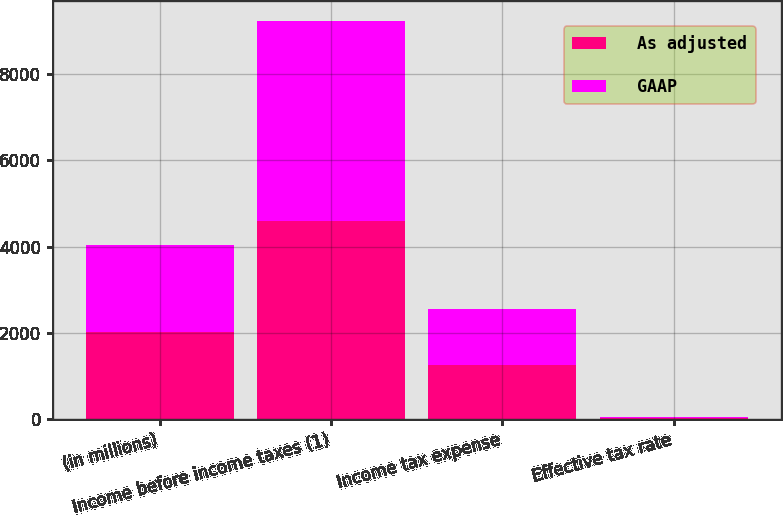Convert chart to OTSL. <chart><loc_0><loc_0><loc_500><loc_500><stacked_bar_chart><ecel><fcel>(in millions)<fcel>Income before income taxes (1)<fcel>Income tax expense<fcel>Effective tax rate<nl><fcel>As adjusted<fcel>2015<fcel>4595<fcel>1250<fcel>27.2<nl><fcel>GAAP<fcel>2015<fcel>4625<fcel>1312<fcel>28.4<nl></chart> 